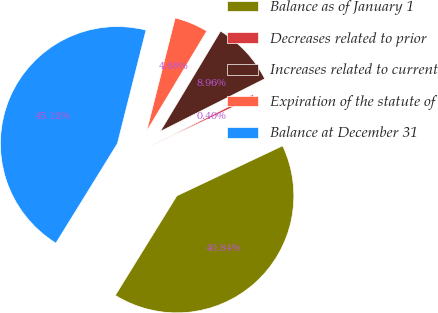Convert chart to OTSL. <chart><loc_0><loc_0><loc_500><loc_500><pie_chart><fcel>Balance as of January 1<fcel>Decreases related to prior<fcel>Increases related to current<fcel>Expiration of the statute of<fcel>Balance at December 31<nl><fcel>40.84%<fcel>0.4%<fcel>8.96%<fcel>4.68%<fcel>45.12%<nl></chart> 